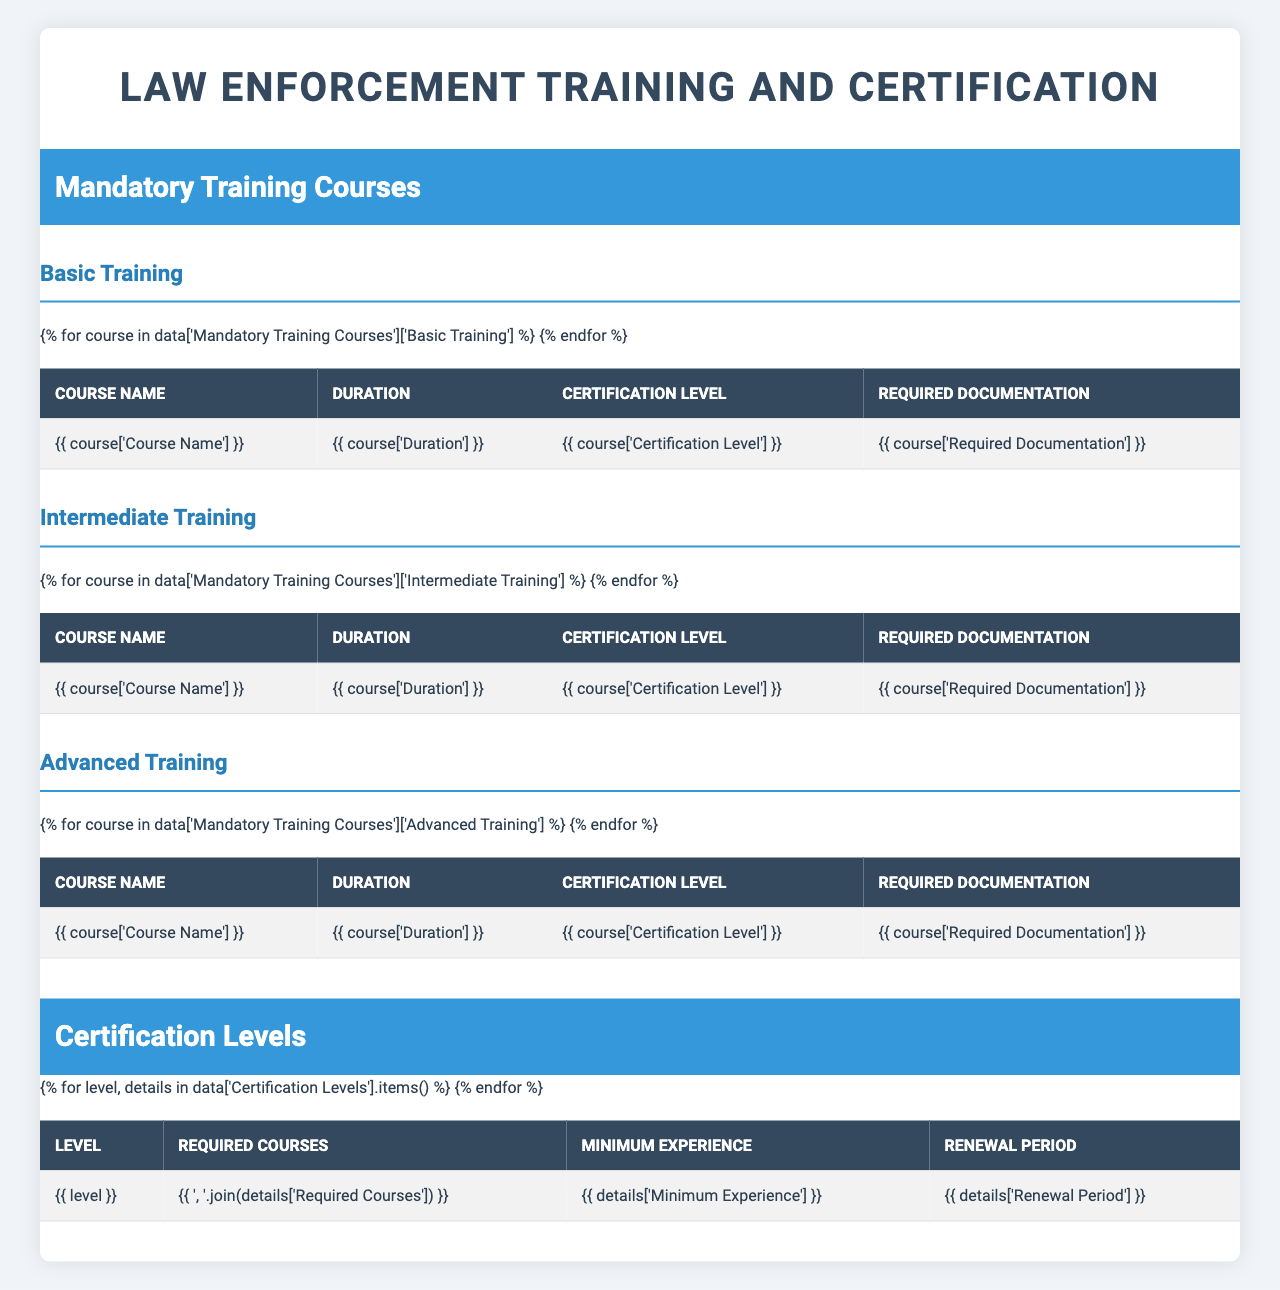What is the duration of the Police Academy course? According to the table, the duration of the Police Academy course is listed as 6 months.
Answer: 6 months Which course is required to achieve the certification level of Detective? The certification level of Detective requires completion of the "Advanced Investigative Techniques" course, as stated in the Certification Levels section.
Answer: Advanced Investigative Techniques What is the minimum experience needed for a SWAT Team Member? The table indicates that a SWAT Team Member requires a minimum of 3 years of experience.
Answer: 3 years Is a Background check clearance required for Firearms Proficiency certification? The required documentation for Firearms Proficiency includes a weapons handling safety certificate, but it does not mention a background check clearance; therefore, the answer is no.
Answer: No How many courses are required for a Senior Patrol Officer certification? The Senior Patrol Officer requires two courses: "Crisis Intervention" and "Domestic Violence Response."
Answer: 2 courses What is the renewal period for a Detective certification? According to the table, the renewal period for a Detective certification is biennial, meaning it needs to be renewed every two years.
Answer: Biennial How does the certification path differ between Patrol Officer and Senior Patrol Officer in terms of required experience? A Patrol Officer requires 0-2 years of experience, while a Senior Patrol Officer requires 3-5 years, showing that a minimum of 3 years is necessary for advancement to Senior Patrol Officer.
Answer: 3 years If a law enforcement officer wants to be a Sergeant, which courses must they complete? The required courses listed for Sergeant certification are "Leadership and Management" and the "Field Training Officer Program."
Answer: Leadership and Management, Field Training Officer Program Which training level includes the course "Tactical Response"? The "Tactical Response" course is included in the Advanced Training level, specifically for those seeking the SWAT Team Member certification.
Answer: Advanced Training Calculate the total duration of all courses required to achieve Patrol Officer certification. The required courses for Patrol Officer are "Police Academy" (6 months), "Firearms Proficiency" (2 weeks), and "Emergency Vehicle Operations" (1 week); converting everything to weeks: 6 months = 26 weeks + 2 weeks + 1 week = 29 weeks total.
Answer: 29 weeks What documentation is required for the Field Training Officer Program? The required documentation for the Field Training Officer Program includes a supervisor recommendation and 3 years of experience, as stated in the table.
Answer: Supervisor recommendation, 3 years of experience 